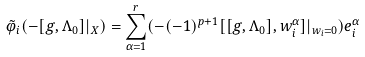Convert formula to latex. <formula><loc_0><loc_0><loc_500><loc_500>\tilde { \varphi } _ { i } ( - [ g , \Lambda _ { 0 } ] | _ { X } ) = \sum _ { \alpha = 1 } ^ { r } ( - ( - 1 ) ^ { p + 1 } [ [ g , \Lambda _ { 0 } ] , w _ { i } ^ { \alpha } ] | _ { w _ { i } = 0 } ) e _ { i } ^ { \alpha }</formula> 